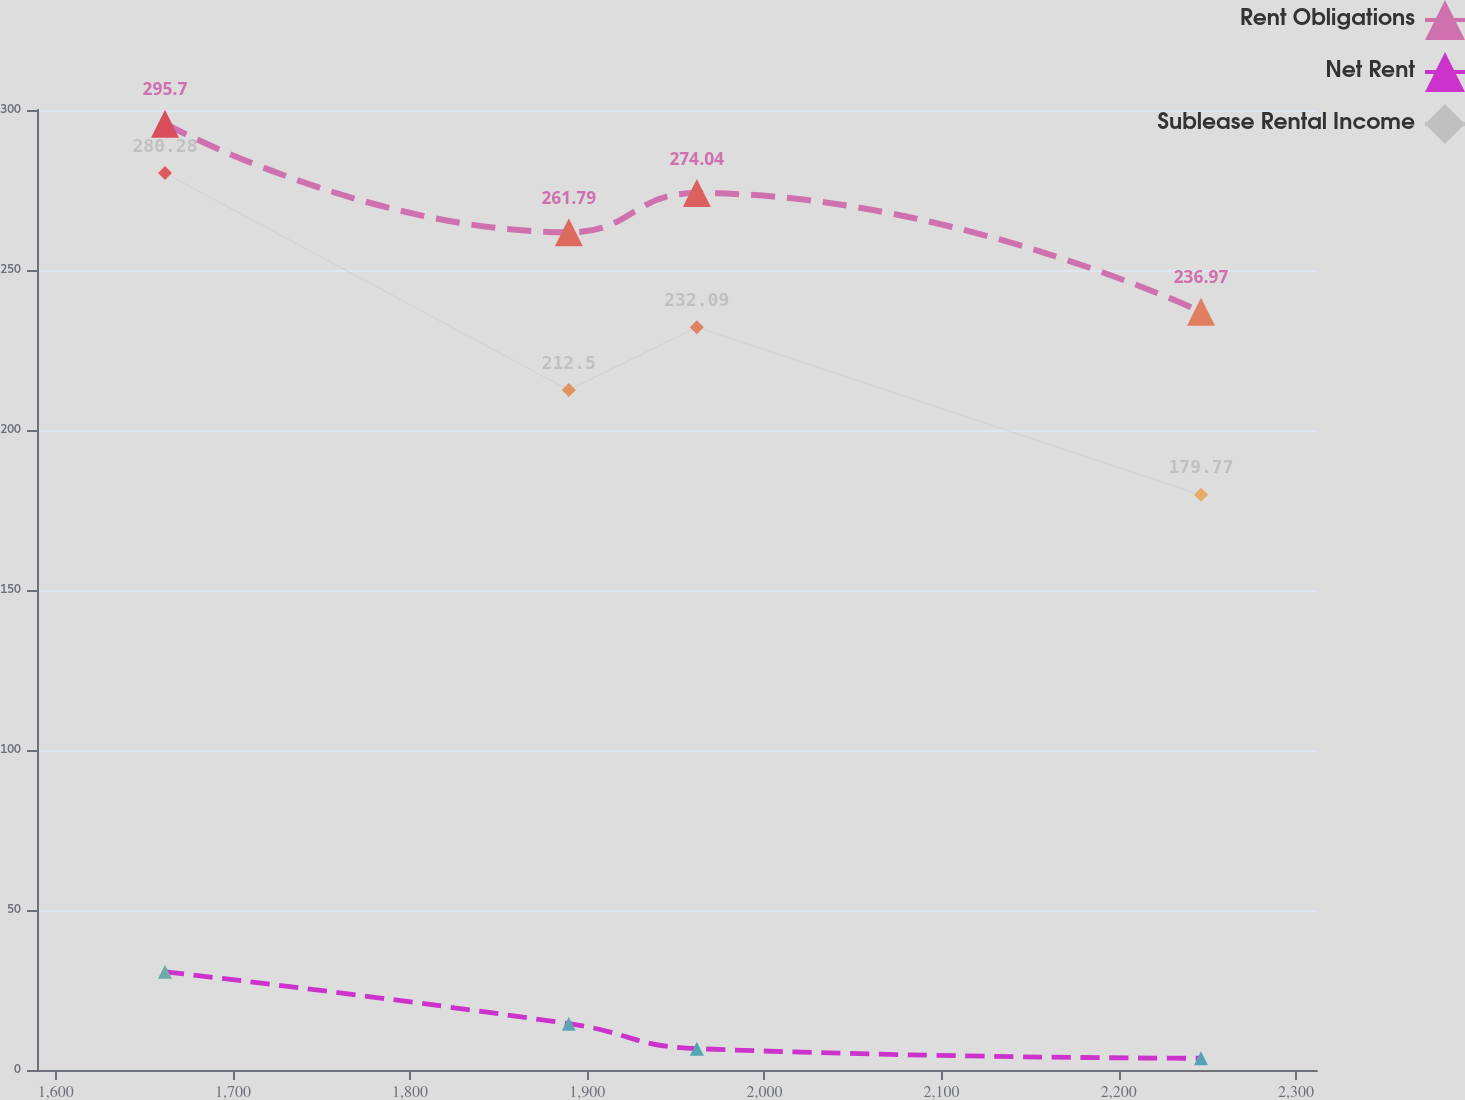Convert chart. <chart><loc_0><loc_0><loc_500><loc_500><line_chart><ecel><fcel>Rent Obligations<fcel>Net Rent<fcel>Sublease Rental Income<nl><fcel>1661.66<fcel>295.7<fcel>30.69<fcel>280.28<nl><fcel>1889.57<fcel>261.79<fcel>14.48<fcel>212.5<nl><fcel>1961.82<fcel>274.04<fcel>6.67<fcel>232.09<nl><fcel>2246.43<fcel>236.97<fcel>3.67<fcel>179.77<nl><fcel>2384.14<fcel>173.24<fcel>0.67<fcel>139.65<nl></chart> 